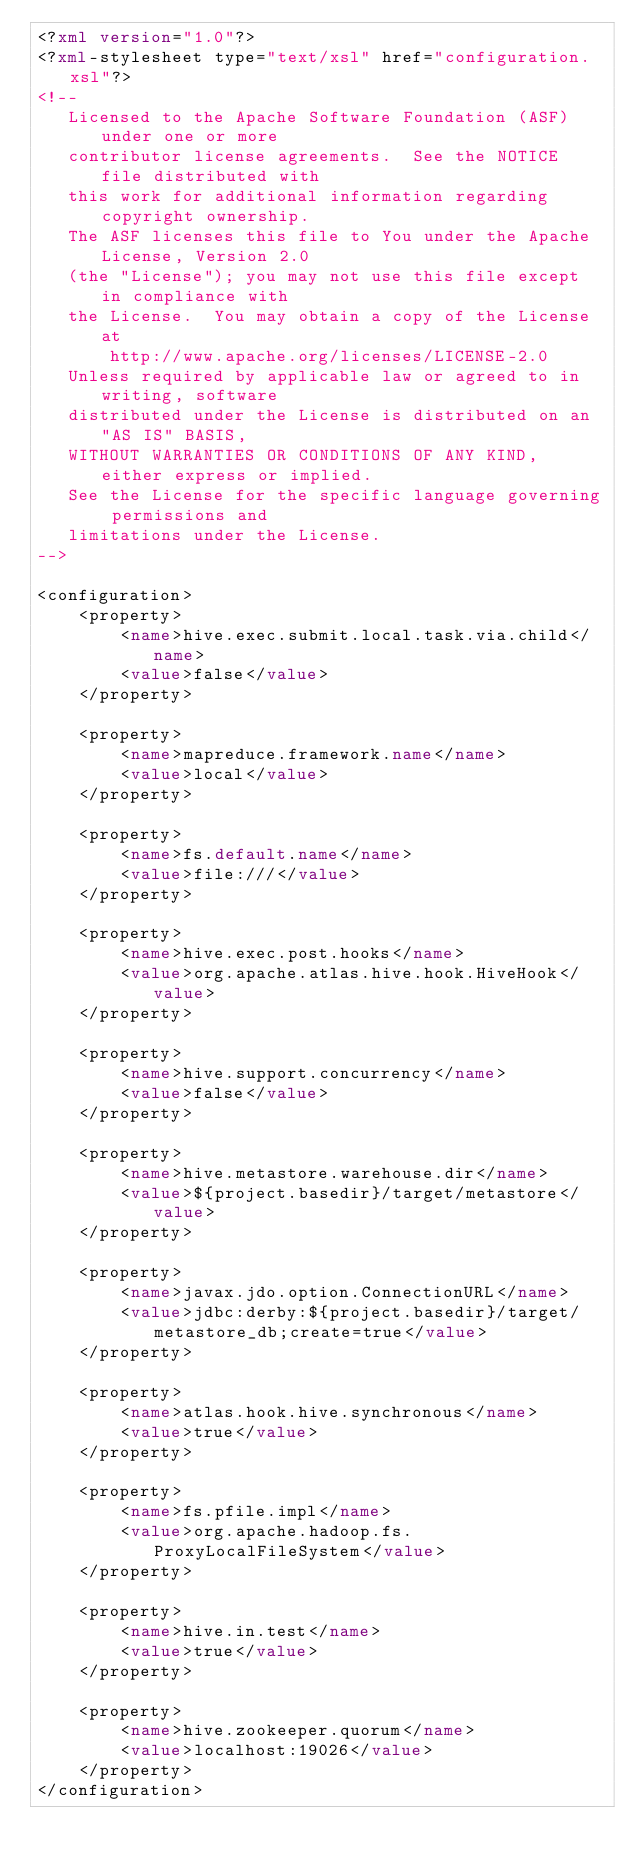Convert code to text. <code><loc_0><loc_0><loc_500><loc_500><_XML_><?xml version="1.0"?>
<?xml-stylesheet type="text/xsl" href="configuration.xsl"?>
<!--
   Licensed to the Apache Software Foundation (ASF) under one or more
   contributor license agreements.  See the NOTICE file distributed with
   this work for additional information regarding copyright ownership.
   The ASF licenses this file to You under the Apache License, Version 2.0
   (the "License"); you may not use this file except in compliance with
   the License.  You may obtain a copy of the License at
       http://www.apache.org/licenses/LICENSE-2.0
   Unless required by applicable law or agreed to in writing, software
   distributed under the License is distributed on an "AS IS" BASIS,
   WITHOUT WARRANTIES OR CONDITIONS OF ANY KIND, either express or implied.
   See the License for the specific language governing permissions and
   limitations under the License.
-->

<configuration>
    <property>
        <name>hive.exec.submit.local.task.via.child</name>
        <value>false</value>
    </property>

    <property>
        <name>mapreduce.framework.name</name>
        <value>local</value>
    </property>

    <property>
        <name>fs.default.name</name>
        <value>file:///</value>
    </property>

    <property>
        <name>hive.exec.post.hooks</name>
        <value>org.apache.atlas.hive.hook.HiveHook</value>
    </property>

    <property>
        <name>hive.support.concurrency</name>
        <value>false</value>
    </property>

    <property>
        <name>hive.metastore.warehouse.dir</name>
        <value>${project.basedir}/target/metastore</value>
    </property>

    <property>
        <name>javax.jdo.option.ConnectionURL</name>
        <value>jdbc:derby:${project.basedir}/target/metastore_db;create=true</value>
    </property>

    <property>
        <name>atlas.hook.hive.synchronous</name>
        <value>true</value>
    </property>

    <property>
        <name>fs.pfile.impl</name>
        <value>org.apache.hadoop.fs.ProxyLocalFileSystem</value>
    </property>

    <property>
        <name>hive.in.test</name>
        <value>true</value>
    </property>

    <property>
        <name>hive.zookeeper.quorum</name>
        <value>localhost:19026</value>
    </property>
</configuration></code> 